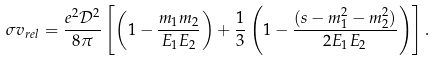<formula> <loc_0><loc_0><loc_500><loc_500>\sigma v _ { r e l } = \frac { e ^ { 2 } \mathcal { D } ^ { 2 } } { 8 \pi } \left [ \left ( 1 - \frac { m _ { 1 } m _ { 2 } } { E _ { 1 } E _ { 2 } } \right ) + \frac { 1 } { 3 } \left ( 1 - \frac { ( s - m _ { 1 } ^ { 2 } - m _ { 2 } ^ { 2 } ) } { 2 E _ { 1 } E _ { 2 } } \right ) \right ] .</formula> 